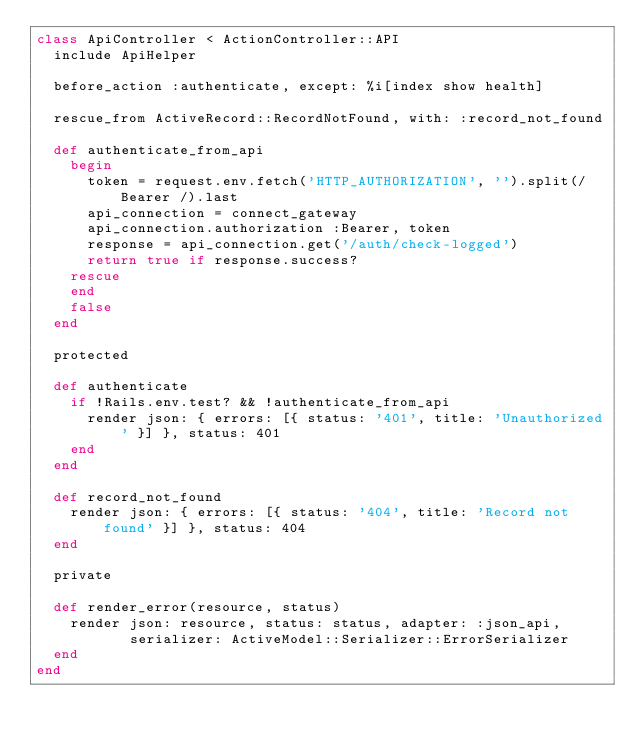Convert code to text. <code><loc_0><loc_0><loc_500><loc_500><_Ruby_>class ApiController < ActionController::API
  include ApiHelper

  before_action :authenticate, except: %i[index show health]

  rescue_from ActiveRecord::RecordNotFound, with: :record_not_found

  def authenticate_from_api
    begin
      token = request.env.fetch('HTTP_AUTHORIZATION', '').split(/Bearer /).last
      api_connection = connect_gateway
      api_connection.authorization :Bearer, token
      response = api_connection.get('/auth/check-logged')
      return true if response.success?
    rescue
    end
    false
  end

  protected

  def authenticate
    if !Rails.env.test? && !authenticate_from_api
      render json: { errors: [{ status: '401', title: 'Unauthorized' }] }, status: 401
    end
  end

  def record_not_found
    render json: { errors: [{ status: '404', title: 'Record not found' }] }, status: 404
  end

  private

  def render_error(resource, status)
    render json: resource, status: status, adapter: :json_api,
           serializer: ActiveModel::Serializer::ErrorSerializer
  end
end
</code> 